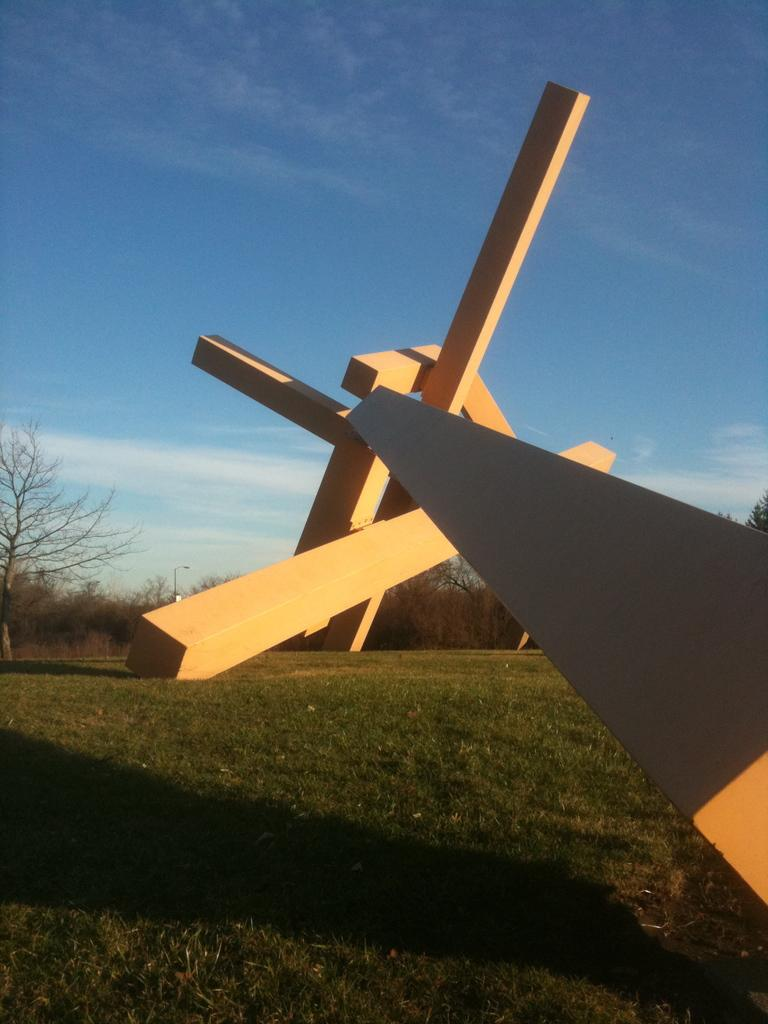What type of vegetation can be seen in the image? There is grass and trees in the image. What part of the natural environment is visible in the image? The sky is visible in the image. How many hands are visible in the image? There are no hands visible in the image. What achievement is the apple celebrating in the image? There is no apple present in the image, and therefore no achievement can be celebrated. 